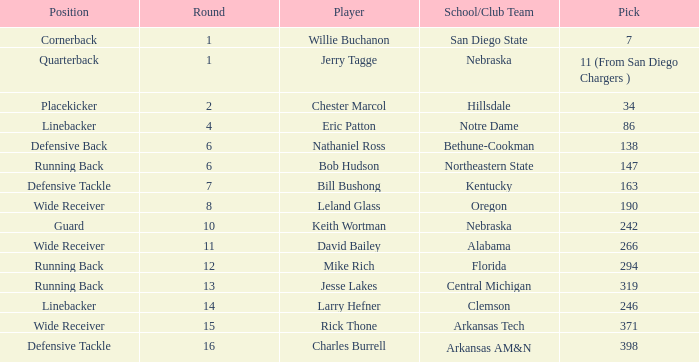Which pick has a school/club team that is kentucky? 163.0. 